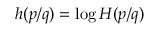<formula> <loc_0><loc_0><loc_500><loc_500>h ( p / q ) = \log H ( p / q )</formula> 